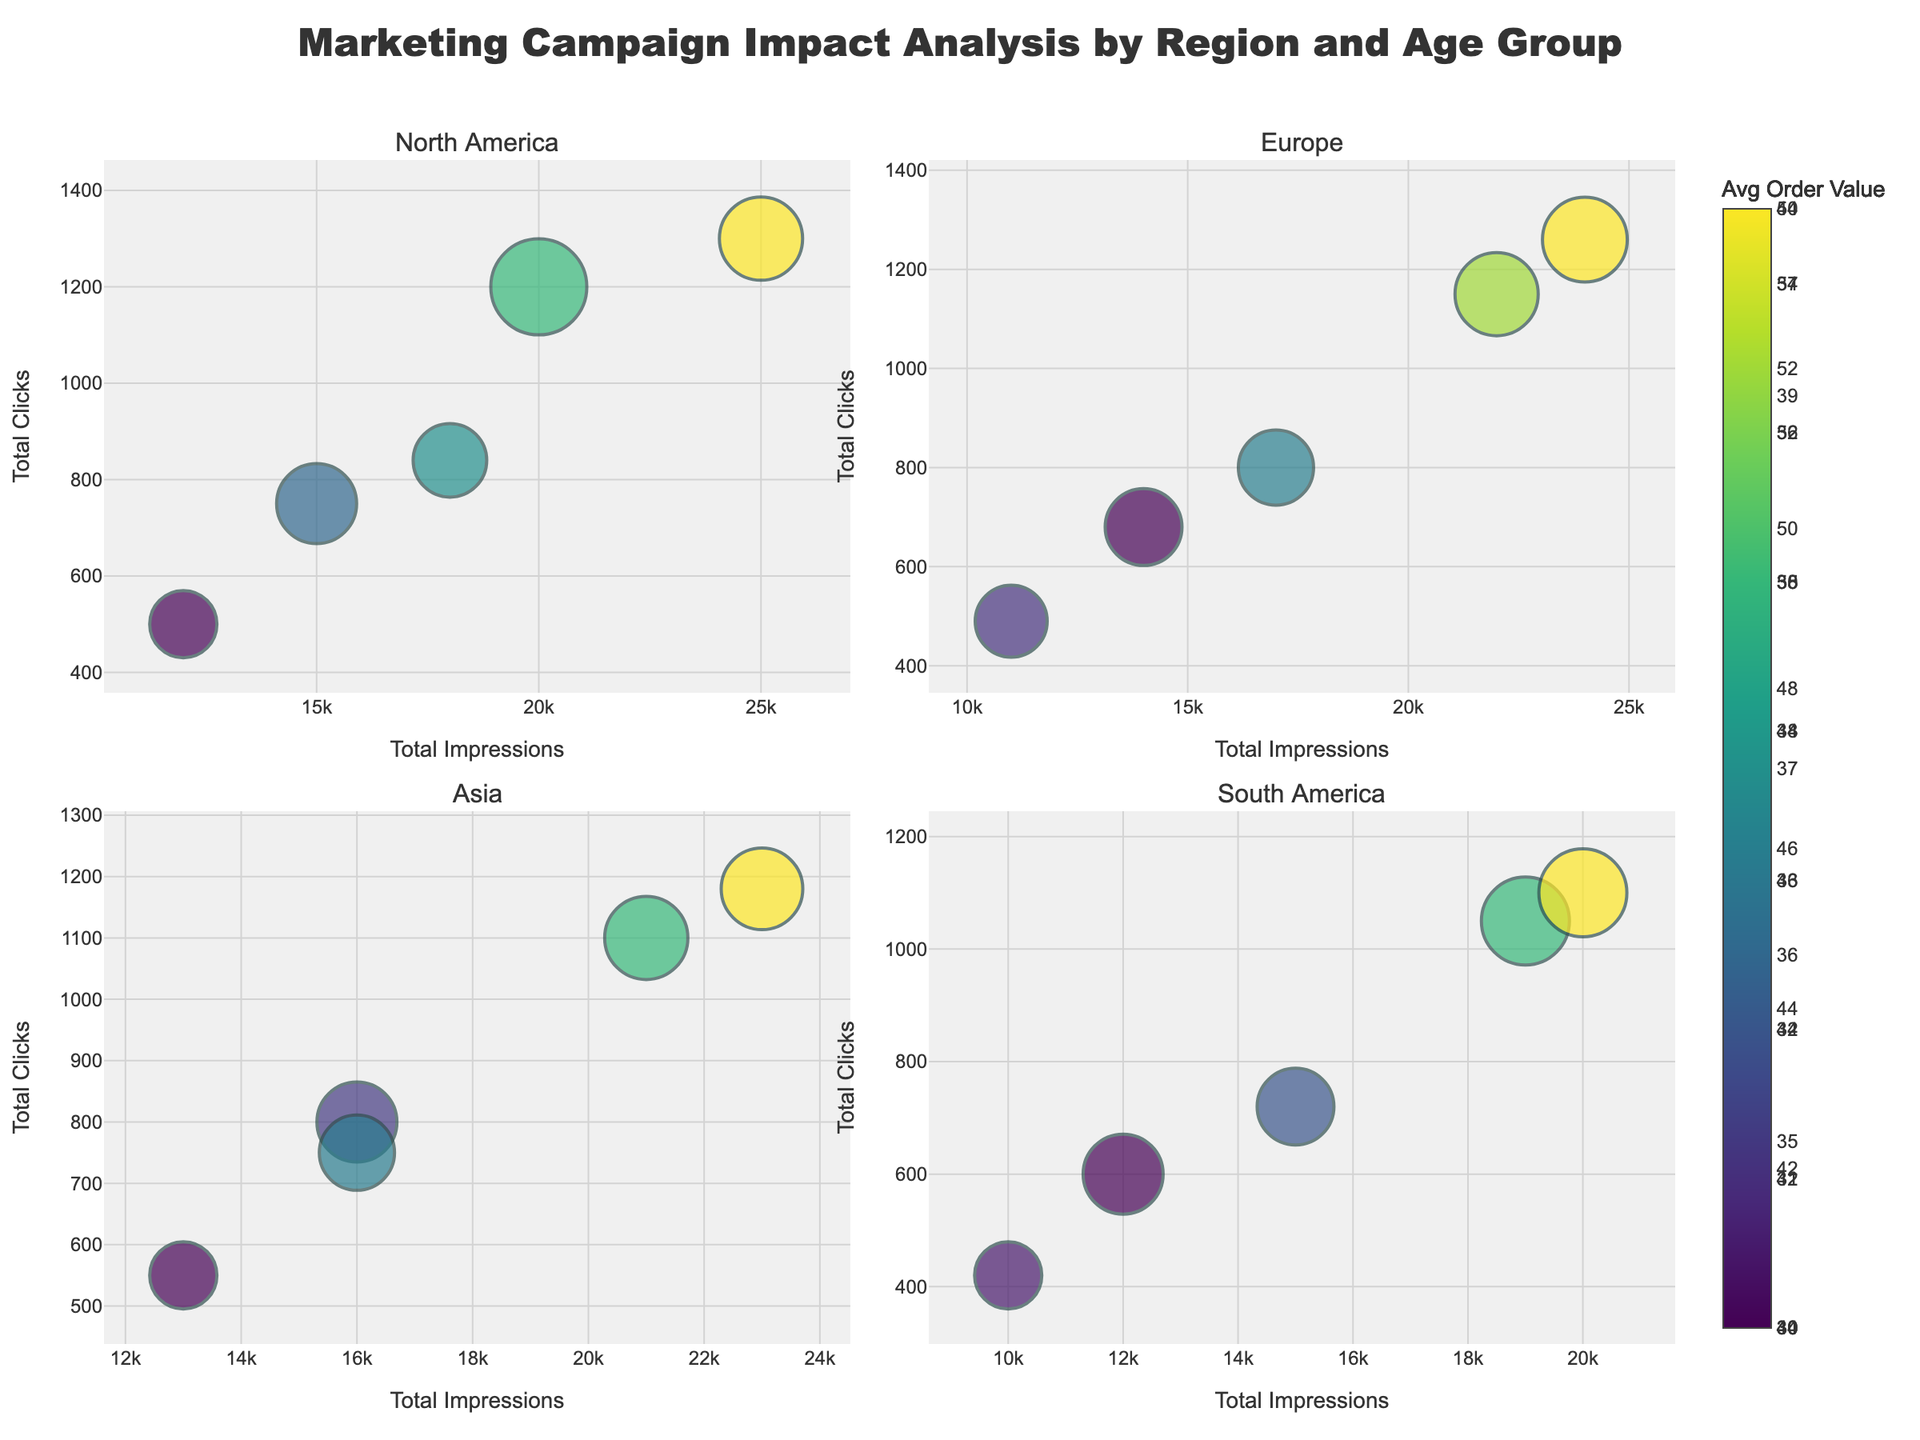How many regions are represented in the figure? The subplot titles indicate the regions. Looking at the subplot titles, there are four regions: North America, Europe, Asia, and South America.
Answer: 4 What does the size of the bubbles represent? The size of the bubbles is proportional to the conversion rate for each age group. Larger bubbles indicate a higher conversion rate.
Answer: Conversion rate Which region has the bubble with the highest conversion rate? By examining the size of the bubbles in each subplot, Asia has a bubble larger than others, especially for the 25-34 age group, representing the highest conversion rate.
Answer: Asia What does the color of the bubbles signify? According to the legend in the figure, the color of the bubbles represents the average order value. Darker bubbles in a Viridis colorscale indicate a higher average order value.
Answer: Average order value Which age group in North America has the highest total clicks? By looking at the y-axis values and comparing the bubbles' positions, the age group 35-44 in North America has the highest total clicks.
Answer: 35-44 What is the average conversion rate in Europe? To find the average conversion rate in Europe, sum up the conversion rates for each age group in Europe and divide by the number of age groups: (0.048 + 0.052 + 0.053 + 0.047 + 0.045) / 5 = 0.049
Answer: 0.049 Which region has the smallest average order value? By comparing the colors of the bubbles across regions and referencing the color bar, South America has the lightest bubbles, indicating the smallest average order value.
Answer: South America How do the total impressions for the age group 55+ in Europe and Asia compare? By referring to the x-axis values in the Europe and Asia subplots, the 55+ group in Europe has 11,000 impressions, while the 55+ group in Asia has 13,000 impressions. Therefore, Asia has higher impressions for this age group.
Answer: Asia What is the relationship between total impressions and total clicks for the age group 25-34 in South America? In the South America subplot, locate the bubble for the 25-34 age group. It shows that with 19,000 total impressions, there are 1,050 total clicks. This suggests a positive relationship between impressions and clicks.
Answer: Positive relationship Does the conversion rate for the 45-54 age group in Asia match that in South America? By comparing the bubble sizes for the 45-54 age group in the Asia and South America subplots, both regions have a conversion rate of 0.047 for this age group, hence they match.
Answer: Yes 